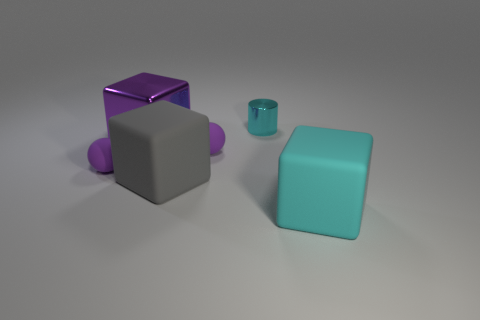What number of other things are the same color as the small shiny object?
Offer a very short reply. 1. The matte ball right of the big matte thing behind the block that is on the right side of the small cylinder is what color?
Give a very brief answer. Purple. Are there an equal number of tiny cyan cylinders that are left of the cyan cylinder and tiny gray rubber objects?
Offer a terse response. Yes. There is a cube right of the cylinder; is its size the same as the small cyan object?
Your answer should be compact. No. How many small matte things are there?
Make the answer very short. 2. What number of objects are both in front of the tiny cylinder and to the right of the purple shiny thing?
Keep it short and to the point. 3. Are there any large things that have the same material as the tiny cylinder?
Ensure brevity in your answer.  Yes. What material is the large block on the left side of the big matte block that is left of the cyan block?
Keep it short and to the point. Metal. Are there the same number of small shiny cylinders that are in front of the large cyan rubber thing and large cubes to the right of the large gray cube?
Give a very brief answer. No. Is the large cyan rubber object the same shape as the small metal thing?
Provide a short and direct response. No. 